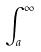Convert formula to latex. <formula><loc_0><loc_0><loc_500><loc_500>\int _ { a } ^ { \infty }</formula> 